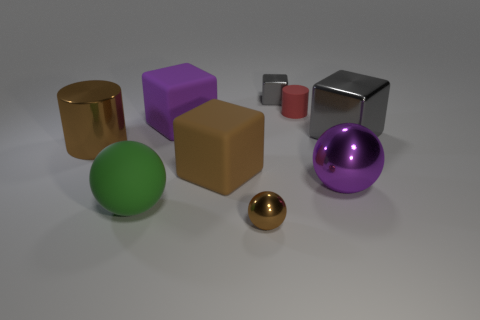Which objects in the image could roll if pushed? The green sphere and the smaller golden sphere can roll because of their perfectly round shapes. Which of the objects appears to be the most reflective? The silver cube seems to be the most reflective, with a surface that mirrors the environment clearly. 